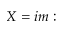Convert formula to latex. <formula><loc_0><loc_0><loc_500><loc_500>X = i m \colon</formula> 